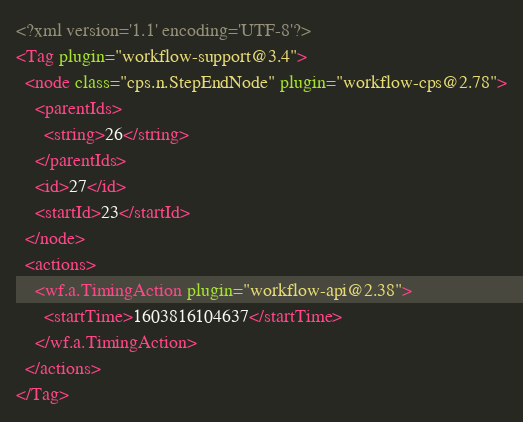Convert code to text. <code><loc_0><loc_0><loc_500><loc_500><_XML_><?xml version='1.1' encoding='UTF-8'?>
<Tag plugin="workflow-support@3.4">
  <node class="cps.n.StepEndNode" plugin="workflow-cps@2.78">
    <parentIds>
      <string>26</string>
    </parentIds>
    <id>27</id>
    <startId>23</startId>
  </node>
  <actions>
    <wf.a.TimingAction plugin="workflow-api@2.38">
      <startTime>1603816104637</startTime>
    </wf.a.TimingAction>
  </actions>
</Tag></code> 